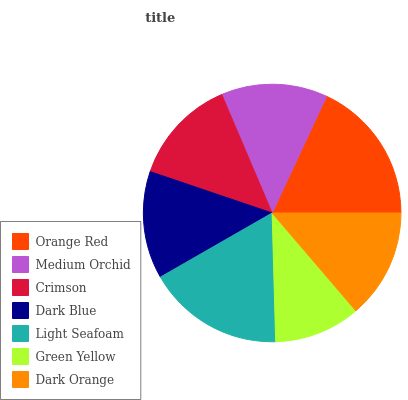Is Green Yellow the minimum?
Answer yes or no. Yes. Is Orange Red the maximum?
Answer yes or no. Yes. Is Medium Orchid the minimum?
Answer yes or no. No. Is Medium Orchid the maximum?
Answer yes or no. No. Is Orange Red greater than Medium Orchid?
Answer yes or no. Yes. Is Medium Orchid less than Orange Red?
Answer yes or no. Yes. Is Medium Orchid greater than Orange Red?
Answer yes or no. No. Is Orange Red less than Medium Orchid?
Answer yes or no. No. Is Dark Blue the high median?
Answer yes or no. Yes. Is Dark Blue the low median?
Answer yes or no. Yes. Is Orange Red the high median?
Answer yes or no. No. Is Dark Orange the low median?
Answer yes or no. No. 